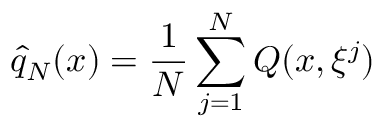Convert formula to latex. <formula><loc_0><loc_0><loc_500><loc_500>{ \hat { q } } _ { N } ( x ) = { \frac { 1 } { N } } \sum _ { j = 1 } ^ { N } Q ( x , \xi ^ { j } )</formula> 